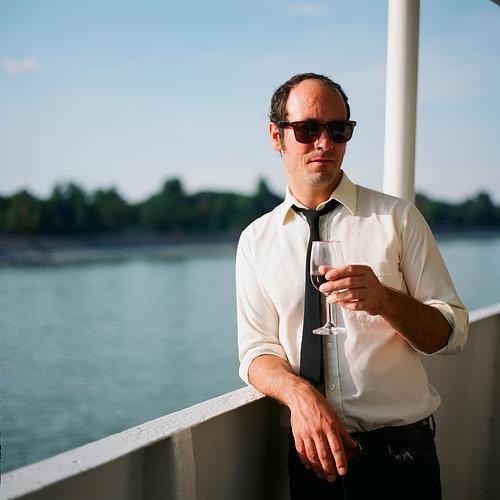How many boats are there?
Give a very brief answer. 0. 